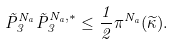Convert formula to latex. <formula><loc_0><loc_0><loc_500><loc_500>\vec { P } _ { 3 } ^ { N _ { a } } \vec { P } _ { 3 } ^ { N _ { a } , \ast } \leq \frac { 1 } { 2 } \pi ^ { N _ { a } } ( \widetilde { \kappa } ) .</formula> 